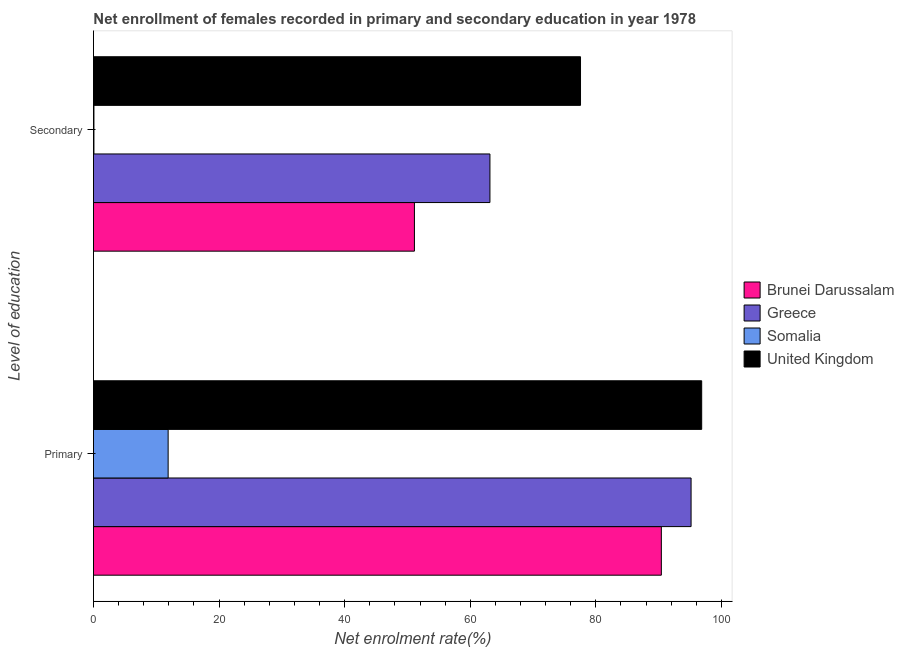How many groups of bars are there?
Offer a terse response. 2. What is the label of the 2nd group of bars from the top?
Keep it short and to the point. Primary. What is the enrollment rate in secondary education in Brunei Darussalam?
Make the answer very short. 51.11. Across all countries, what is the maximum enrollment rate in secondary education?
Give a very brief answer. 77.56. Across all countries, what is the minimum enrollment rate in secondary education?
Provide a short and direct response. 0.07. In which country was the enrollment rate in primary education minimum?
Provide a succinct answer. Somalia. What is the total enrollment rate in primary education in the graph?
Give a very brief answer. 294.34. What is the difference between the enrollment rate in primary education in United Kingdom and that in Somalia?
Your response must be concise. 84.96. What is the difference between the enrollment rate in primary education in Somalia and the enrollment rate in secondary education in Brunei Darussalam?
Your answer should be compact. -39.22. What is the average enrollment rate in secondary education per country?
Give a very brief answer. 47.97. What is the difference between the enrollment rate in secondary education and enrollment rate in primary education in Greece?
Offer a very short reply. -32.03. In how many countries, is the enrollment rate in secondary education greater than 68 %?
Offer a very short reply. 1. What is the ratio of the enrollment rate in secondary education in United Kingdom to that in Greece?
Keep it short and to the point. 1.23. Is the enrollment rate in secondary education in Somalia less than that in Brunei Darussalam?
Make the answer very short. Yes. What does the 4th bar from the top in Secondary represents?
Your response must be concise. Brunei Darussalam. What does the 4th bar from the bottom in Primary represents?
Give a very brief answer. United Kingdom. How many bars are there?
Provide a succinct answer. 8. Are all the bars in the graph horizontal?
Your answer should be very brief. Yes. How many countries are there in the graph?
Provide a succinct answer. 4. What is the title of the graph?
Make the answer very short. Net enrollment of females recorded in primary and secondary education in year 1978. Does "Caribbean small states" appear as one of the legend labels in the graph?
Your response must be concise. No. What is the label or title of the X-axis?
Ensure brevity in your answer.  Net enrolment rate(%). What is the label or title of the Y-axis?
Ensure brevity in your answer.  Level of education. What is the Net enrolment rate(%) in Brunei Darussalam in Primary?
Provide a short and direct response. 90.43. What is the Net enrolment rate(%) in Greece in Primary?
Your answer should be compact. 95.16. What is the Net enrolment rate(%) in Somalia in Primary?
Provide a short and direct response. 11.89. What is the Net enrolment rate(%) of United Kingdom in Primary?
Offer a terse response. 96.85. What is the Net enrolment rate(%) of Brunei Darussalam in Secondary?
Your response must be concise. 51.11. What is the Net enrolment rate(%) in Greece in Secondary?
Offer a very short reply. 63.13. What is the Net enrolment rate(%) of Somalia in Secondary?
Your answer should be very brief. 0.07. What is the Net enrolment rate(%) in United Kingdom in Secondary?
Give a very brief answer. 77.56. Across all Level of education, what is the maximum Net enrolment rate(%) of Brunei Darussalam?
Provide a short and direct response. 90.43. Across all Level of education, what is the maximum Net enrolment rate(%) in Greece?
Make the answer very short. 95.16. Across all Level of education, what is the maximum Net enrolment rate(%) of Somalia?
Offer a very short reply. 11.89. Across all Level of education, what is the maximum Net enrolment rate(%) in United Kingdom?
Offer a very short reply. 96.85. Across all Level of education, what is the minimum Net enrolment rate(%) of Brunei Darussalam?
Provide a short and direct response. 51.11. Across all Level of education, what is the minimum Net enrolment rate(%) of Greece?
Your response must be concise. 63.13. Across all Level of education, what is the minimum Net enrolment rate(%) in Somalia?
Provide a succinct answer. 0.07. Across all Level of education, what is the minimum Net enrolment rate(%) of United Kingdom?
Keep it short and to the point. 77.56. What is the total Net enrolment rate(%) of Brunei Darussalam in the graph?
Offer a very short reply. 141.54. What is the total Net enrolment rate(%) in Greece in the graph?
Your answer should be very brief. 158.3. What is the total Net enrolment rate(%) of Somalia in the graph?
Give a very brief answer. 11.96. What is the total Net enrolment rate(%) in United Kingdom in the graph?
Provide a succinct answer. 174.41. What is the difference between the Net enrolment rate(%) in Brunei Darussalam in Primary and that in Secondary?
Provide a succinct answer. 39.32. What is the difference between the Net enrolment rate(%) in Greece in Primary and that in Secondary?
Your response must be concise. 32.03. What is the difference between the Net enrolment rate(%) in Somalia in Primary and that in Secondary?
Make the answer very short. 11.82. What is the difference between the Net enrolment rate(%) in United Kingdom in Primary and that in Secondary?
Provide a succinct answer. 19.3. What is the difference between the Net enrolment rate(%) in Brunei Darussalam in Primary and the Net enrolment rate(%) in Greece in Secondary?
Your response must be concise. 27.3. What is the difference between the Net enrolment rate(%) in Brunei Darussalam in Primary and the Net enrolment rate(%) in Somalia in Secondary?
Your answer should be very brief. 90.36. What is the difference between the Net enrolment rate(%) of Brunei Darussalam in Primary and the Net enrolment rate(%) of United Kingdom in Secondary?
Offer a terse response. 12.87. What is the difference between the Net enrolment rate(%) in Greece in Primary and the Net enrolment rate(%) in Somalia in Secondary?
Give a very brief answer. 95.09. What is the difference between the Net enrolment rate(%) of Greece in Primary and the Net enrolment rate(%) of United Kingdom in Secondary?
Provide a short and direct response. 17.61. What is the difference between the Net enrolment rate(%) in Somalia in Primary and the Net enrolment rate(%) in United Kingdom in Secondary?
Your response must be concise. -65.67. What is the average Net enrolment rate(%) in Brunei Darussalam per Level of education?
Ensure brevity in your answer.  70.77. What is the average Net enrolment rate(%) of Greece per Level of education?
Ensure brevity in your answer.  79.15. What is the average Net enrolment rate(%) of Somalia per Level of education?
Provide a short and direct response. 5.98. What is the average Net enrolment rate(%) of United Kingdom per Level of education?
Provide a succinct answer. 87.21. What is the difference between the Net enrolment rate(%) in Brunei Darussalam and Net enrolment rate(%) in Greece in Primary?
Keep it short and to the point. -4.73. What is the difference between the Net enrolment rate(%) of Brunei Darussalam and Net enrolment rate(%) of Somalia in Primary?
Keep it short and to the point. 78.54. What is the difference between the Net enrolment rate(%) of Brunei Darussalam and Net enrolment rate(%) of United Kingdom in Primary?
Keep it short and to the point. -6.42. What is the difference between the Net enrolment rate(%) of Greece and Net enrolment rate(%) of Somalia in Primary?
Provide a short and direct response. 83.27. What is the difference between the Net enrolment rate(%) in Greece and Net enrolment rate(%) in United Kingdom in Primary?
Give a very brief answer. -1.69. What is the difference between the Net enrolment rate(%) of Somalia and Net enrolment rate(%) of United Kingdom in Primary?
Your response must be concise. -84.96. What is the difference between the Net enrolment rate(%) in Brunei Darussalam and Net enrolment rate(%) in Greece in Secondary?
Offer a terse response. -12.02. What is the difference between the Net enrolment rate(%) of Brunei Darussalam and Net enrolment rate(%) of Somalia in Secondary?
Make the answer very short. 51.04. What is the difference between the Net enrolment rate(%) in Brunei Darussalam and Net enrolment rate(%) in United Kingdom in Secondary?
Ensure brevity in your answer.  -26.45. What is the difference between the Net enrolment rate(%) of Greece and Net enrolment rate(%) of Somalia in Secondary?
Offer a very short reply. 63.06. What is the difference between the Net enrolment rate(%) of Greece and Net enrolment rate(%) of United Kingdom in Secondary?
Make the answer very short. -14.43. What is the difference between the Net enrolment rate(%) in Somalia and Net enrolment rate(%) in United Kingdom in Secondary?
Make the answer very short. -77.48. What is the ratio of the Net enrolment rate(%) in Brunei Darussalam in Primary to that in Secondary?
Ensure brevity in your answer.  1.77. What is the ratio of the Net enrolment rate(%) of Greece in Primary to that in Secondary?
Keep it short and to the point. 1.51. What is the ratio of the Net enrolment rate(%) of Somalia in Primary to that in Secondary?
Your answer should be compact. 160.1. What is the ratio of the Net enrolment rate(%) in United Kingdom in Primary to that in Secondary?
Provide a succinct answer. 1.25. What is the difference between the highest and the second highest Net enrolment rate(%) in Brunei Darussalam?
Offer a terse response. 39.32. What is the difference between the highest and the second highest Net enrolment rate(%) of Greece?
Give a very brief answer. 32.03. What is the difference between the highest and the second highest Net enrolment rate(%) in Somalia?
Your answer should be compact. 11.82. What is the difference between the highest and the second highest Net enrolment rate(%) in United Kingdom?
Your answer should be compact. 19.3. What is the difference between the highest and the lowest Net enrolment rate(%) in Brunei Darussalam?
Your response must be concise. 39.32. What is the difference between the highest and the lowest Net enrolment rate(%) of Greece?
Make the answer very short. 32.03. What is the difference between the highest and the lowest Net enrolment rate(%) in Somalia?
Offer a terse response. 11.82. What is the difference between the highest and the lowest Net enrolment rate(%) of United Kingdom?
Your response must be concise. 19.3. 